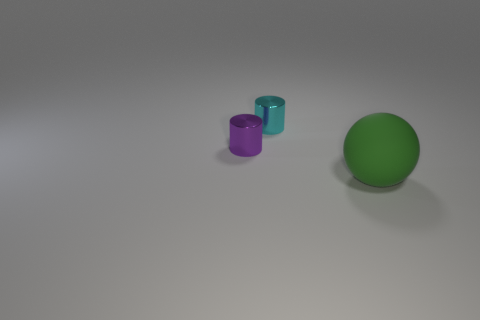There is a metal thing on the left side of the tiny cyan cylinder; does it have the same shape as the thing that is in front of the purple metal cylinder?
Provide a succinct answer. No. How many purple cylinders have the same material as the small purple object?
Make the answer very short. 0. What shape is the thing that is on the left side of the big thing and in front of the cyan object?
Keep it short and to the point. Cylinder. Does the tiny object behind the small purple metal cylinder have the same material as the small purple cylinder?
Provide a short and direct response. Yes. Is there any other thing that is the same material as the tiny purple object?
Make the answer very short. Yes. There is a shiny cylinder that is the same size as the cyan thing; what is its color?
Your response must be concise. Purple. Are there any tiny metallic objects that have the same color as the matte thing?
Give a very brief answer. No. What is the size of the other thing that is made of the same material as the small purple object?
Provide a short and direct response. Small. How many other things are there of the same size as the green rubber thing?
Make the answer very short. 0. What is the sphere right of the small purple shiny thing made of?
Your response must be concise. Rubber. 